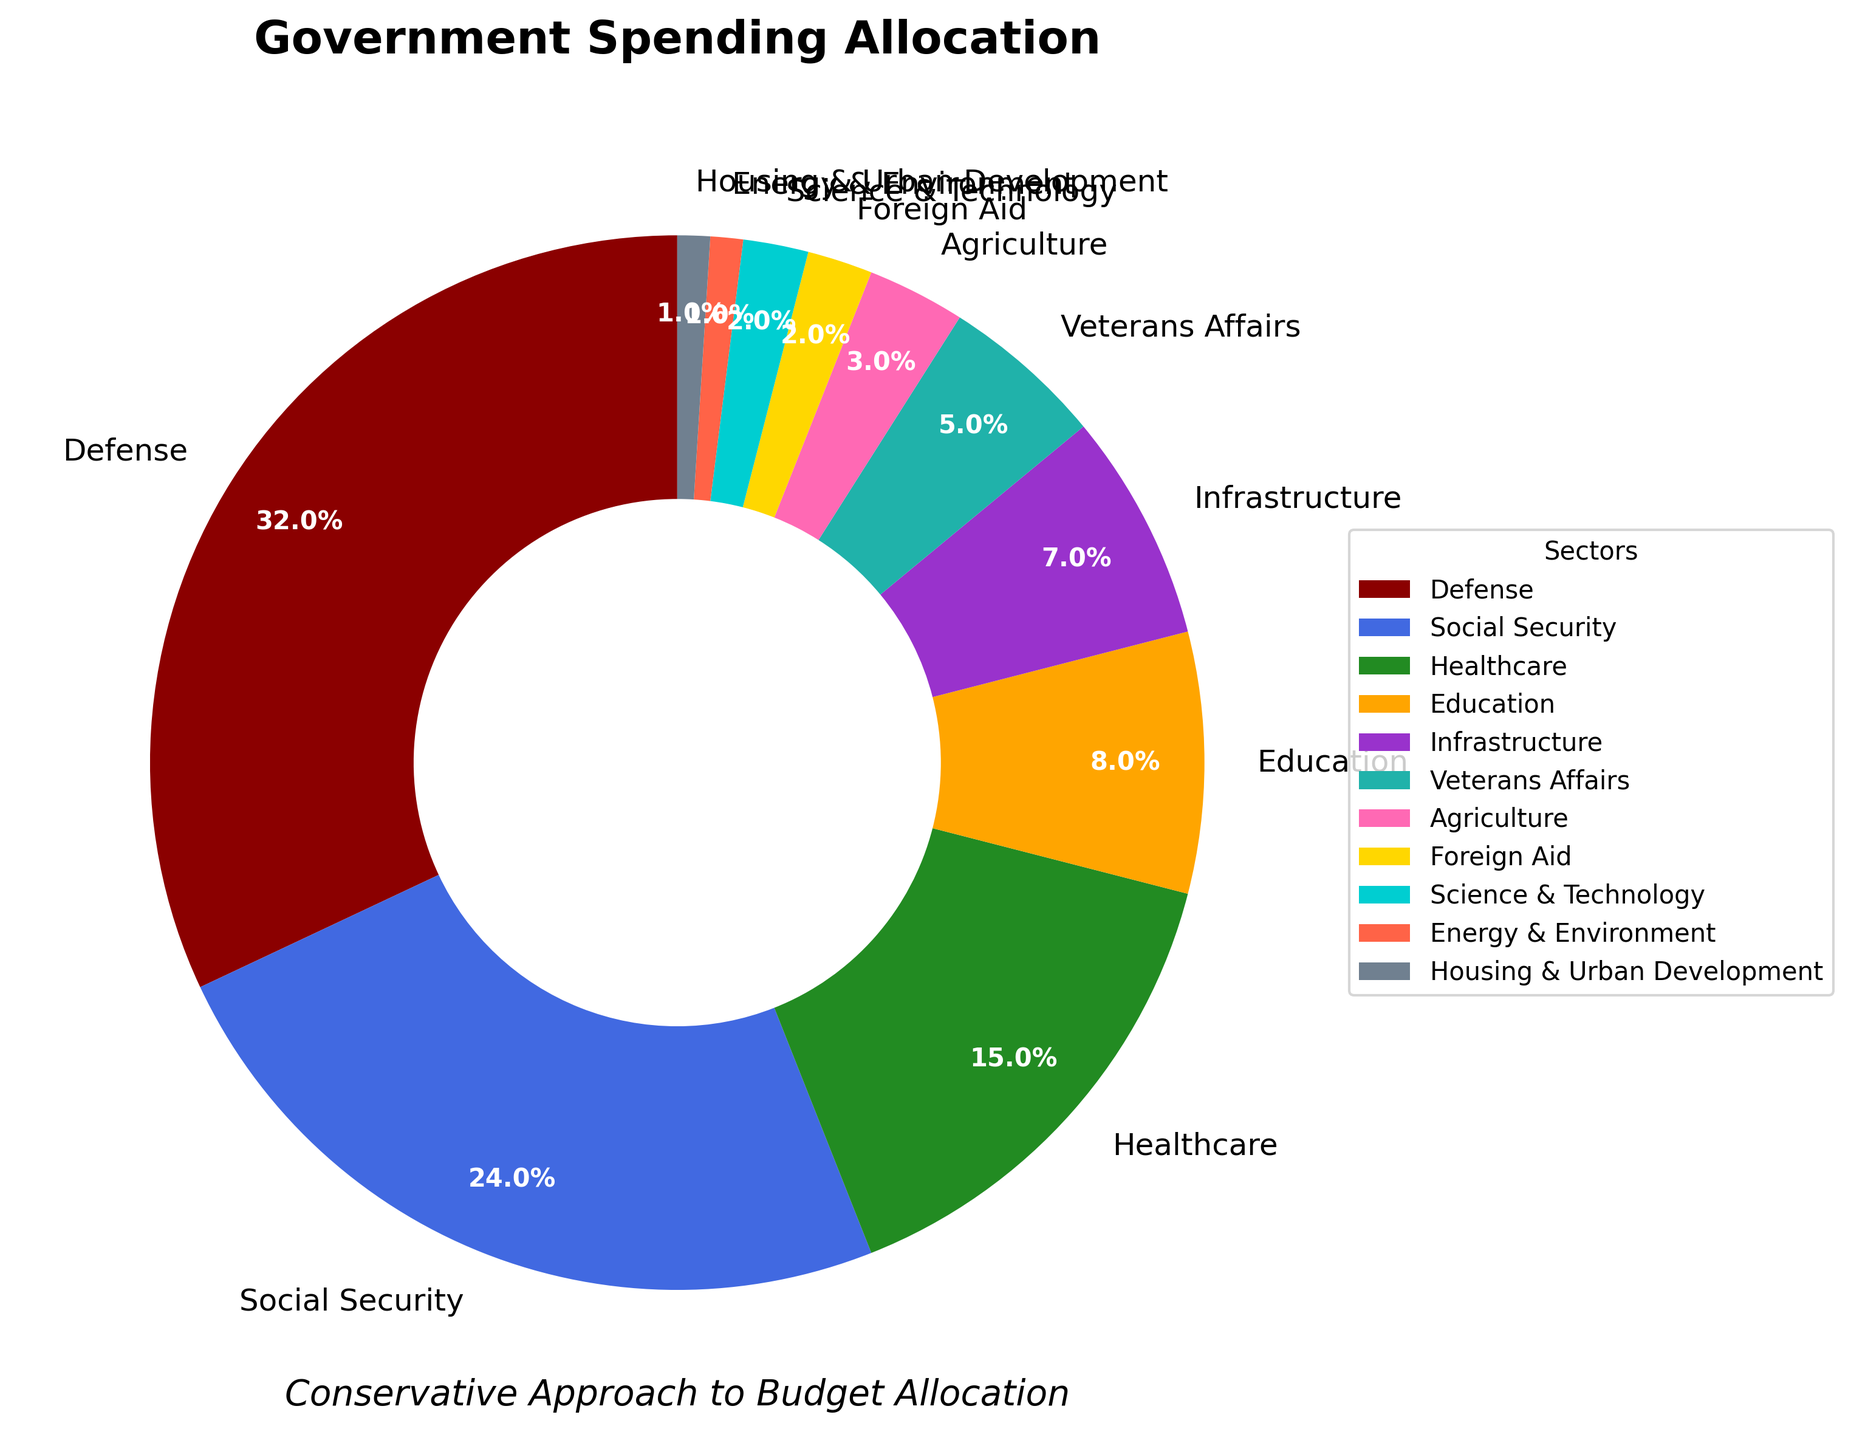What is the largest sector in the government spending allocation? The largest sector is the one with the highest percentage shown in the pie chart. Here, it is Defense with 32%.
Answer: Defense Which sector has the smallest allocation? The smallest sector is the one with the smallest percentage shown in the pie chart. Here, it is Housing & Urban Development with 1%.
Answer: Housing & Urban Development What is the combined percentage of Social Security and Healthcare? To find the combined percentage, add the percentages of Social Security and Healthcare. Social Security is 24% and Healthcare is 15%. So, 24% + 15% = 39%.
Answer: 39% How much higher is the Defense spending percentage compared to Education? Subtract the percentage of Education from the percentage of Defense. Defense is 32% and Education is 8%. So, 32% - 8% = 24%.
Answer: 24% What are the sectors with an allocation of less than 5%? The sectors with less than 5% allocation can be identified by looking at the pie chart segments with percentages under 5%. Here, they are Agriculture (3%), Foreign Aid (2%), Science & Technology (2%), Energy & Environment (1%), and Housing & Urban Development (1%).
Answer: Agriculture, Foreign Aid, Science & Technology, Energy & Environment, Housing & Urban Development How much more is spent on Healthcare compared to Veterans Affairs? The difference can be found by subtracting the percentage of Veterans Affairs from the percentage of Healthcare. Healthcare is 15% and Veterans Affairs is 5%. So, 15% - 5% = 10%.
Answer: 10% What is the total percentage allocation for Infrastructure, Veterans Affairs, and Agriculture? Add the percentages of Infrastructure, Veterans Affairs, and Agriculture. Infrastructure is 7%, Veterans Affairs is 5%, and Agriculture is 3%. So, 7% + 5% + 3% = 15%.
Answer: 15% Which sector comes immediately after Healthcare in terms of percentage allocation? The sector coming immediately after Healthcare in terms of allocation is Education, as Healthcare has 15% and Education has 8%.
Answer: Education What percentage of the government spending is allocated to sectors with 2% or less? Add the percentages of the sectors with 2% or less, which are Foreign Aid (2%), Science & Technology (2%), Energy & Environment (1%), and Housing & Urban Development (1%). So, 2% + 2% + 1% + 1% = 6%.
Answer: 6% Which sector has a greater allocation: Agriculture or Veterans Affairs? Compare the percentages of the two sectors: Agriculture has 3% and Veterans Affairs has 5%. Veterans Affairs has the greater allocation.
Answer: Veterans Affairs 